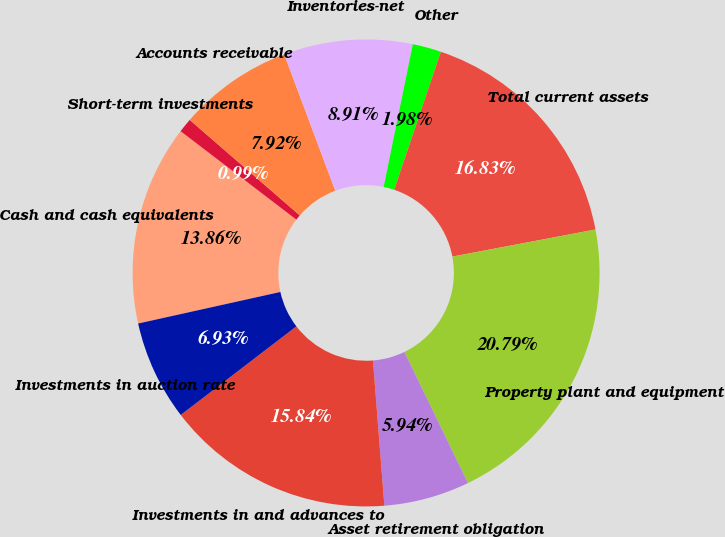Convert chart to OTSL. <chart><loc_0><loc_0><loc_500><loc_500><pie_chart><fcel>Cash and cash equivalents<fcel>Short-term investments<fcel>Accounts receivable<fcel>Inventories-net<fcel>Other<fcel>Total current assets<fcel>Property plant and equipment<fcel>Asset retirement obligation<fcel>Investments in and advances to<fcel>Investments in auction rate<nl><fcel>13.86%<fcel>0.99%<fcel>7.92%<fcel>8.91%<fcel>1.98%<fcel>16.83%<fcel>20.79%<fcel>5.94%<fcel>15.84%<fcel>6.93%<nl></chart> 